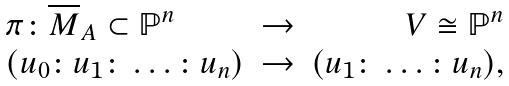Convert formula to latex. <formula><loc_0><loc_0><loc_500><loc_500>\begin{array} { l c r } \pi \colon { \overline { M } } _ { A } \subset { \mathbb { P } } ^ { n } & \rightarrow & V \cong { \mathbb { P } } ^ { n } \\ ( u _ { 0 } \colon u _ { 1 } \colon \dots \colon u _ { n } ) & \rightarrow & ( u _ { 1 } \colon \dots \colon u _ { n } ) , \end{array}</formula> 